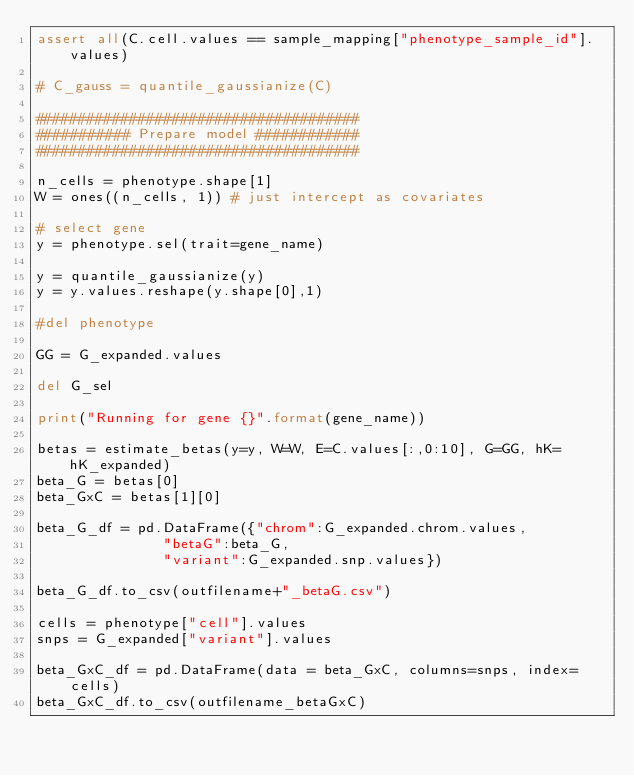<code> <loc_0><loc_0><loc_500><loc_500><_Python_>assert all(C.cell.values == sample_mapping["phenotype_sample_id"].values)

# C_gauss = quantile_gaussianize(C)

######################################
########### Prepare model ############
######################################

n_cells = phenotype.shape[1]
W = ones((n_cells, 1)) # just intercept as covariates

# select gene
y = phenotype.sel(trait=gene_name)

y = quantile_gaussianize(y)
y = y.values.reshape(y.shape[0],1)

#del phenotype

GG = G_expanded.values

del G_sel

print("Running for gene {}".format(gene_name))

betas = estimate_betas(y=y, W=W, E=C.values[:,0:10], G=GG, hK=hK_expanded)
beta_G = betas[0]
beta_GxC = betas[1][0]

beta_G_df = pd.DataFrame({"chrom":G_expanded.chrom.values,
               "betaG":beta_G,
               "variant":G_expanded.snp.values})

beta_G_df.to_csv(outfilename+"_betaG.csv")

cells = phenotype["cell"].values
snps = G_expanded["variant"].values

beta_GxC_df = pd.DataFrame(data = beta_GxC, columns=snps, index=cells)
beta_GxC_df.to_csv(outfilename_betaGxC)
</code> 